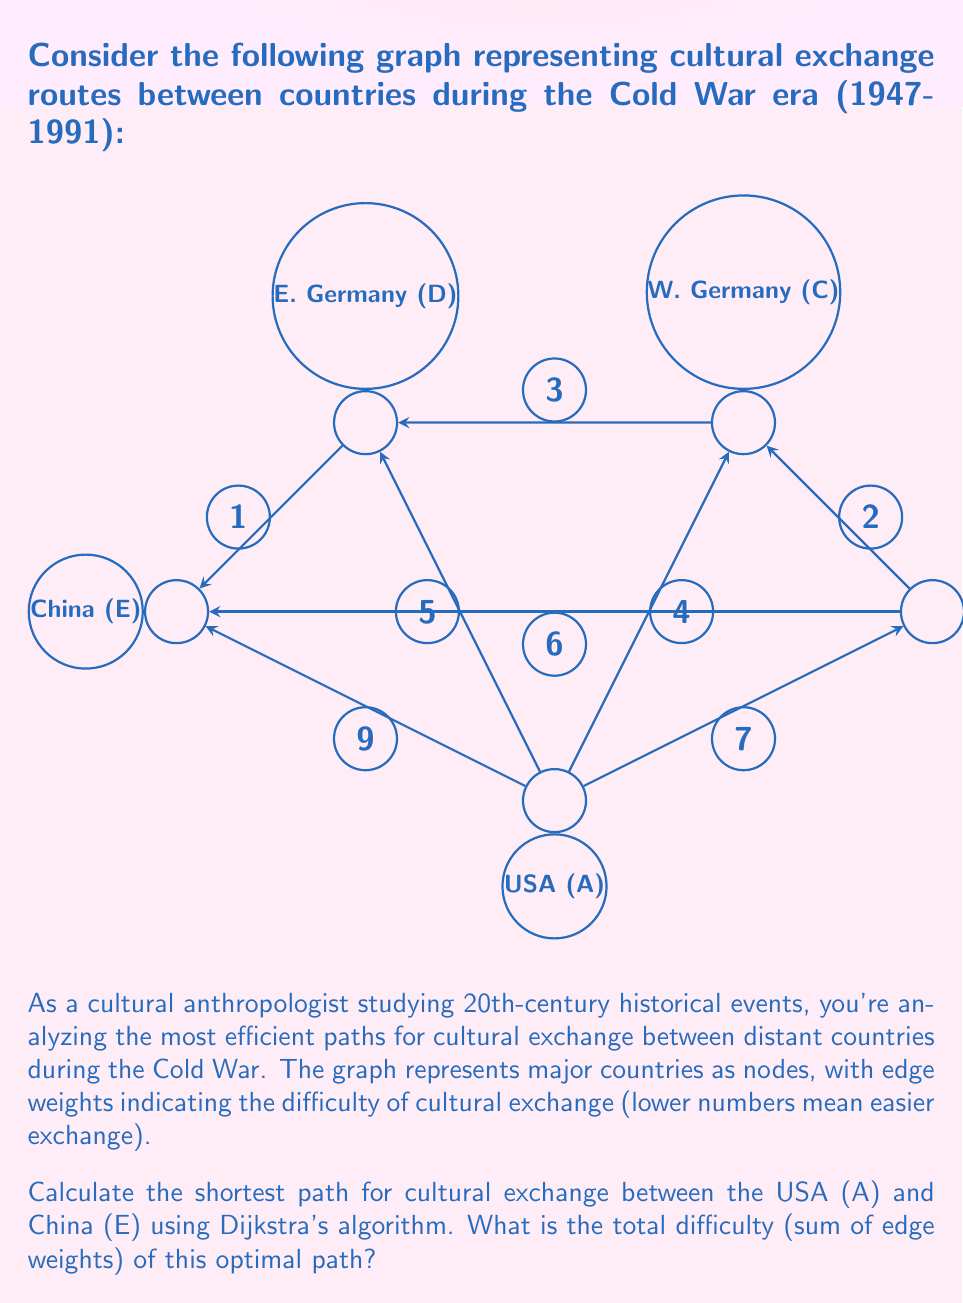Teach me how to tackle this problem. To solve this problem, we'll use Dijkstra's algorithm to find the shortest path from the USA (A) to China (E). Here's a step-by-step explanation:

1) Initialize:
   - Set distance to A as 0, all others as infinity.
   - Set all nodes as unvisited.
   - Set A as the current node.

2) For the current node, consider all unvisited neighbors and calculate their tentative distances:
   - A to B: 7
   - A to C: 4
   - A to D: 5
   - A to E: 9

3) Mark A as visited. Set C as the current node (lowest tentative distance).

4) From C:
   - C to B: 4 + 2 = 6 (better than direct A to B)
   - C to D: 4 + 3 = 7

5) Mark C as visited. Set B as the current node.

6) From B:
   - B to E: 6 + 6 = 12 (better than direct A to E)

7) Mark B as visited. Set D as the current node.

8) From D:
   - D to E: 5 + 1 = 6 (better than via B)

9) Mark D as visited. E is the only unvisited node left.

The shortest path is A -> D -> E, with a total difficulty of 5 + 1 = 6.
Answer: 6 